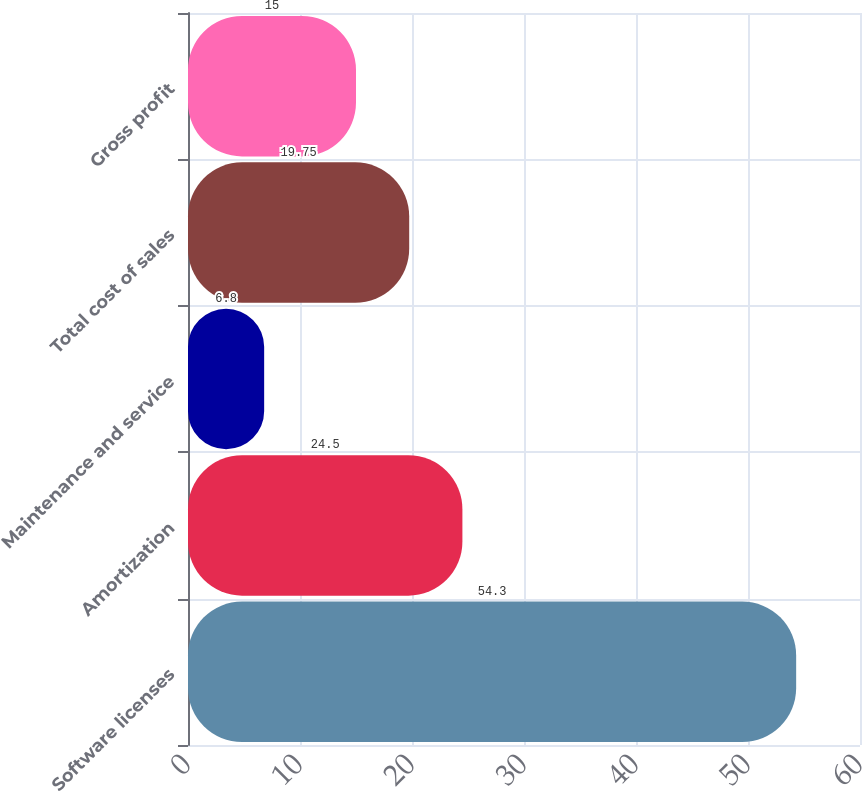<chart> <loc_0><loc_0><loc_500><loc_500><bar_chart><fcel>Software licenses<fcel>Amortization<fcel>Maintenance and service<fcel>Total cost of sales<fcel>Gross profit<nl><fcel>54.3<fcel>24.5<fcel>6.8<fcel>19.75<fcel>15<nl></chart> 